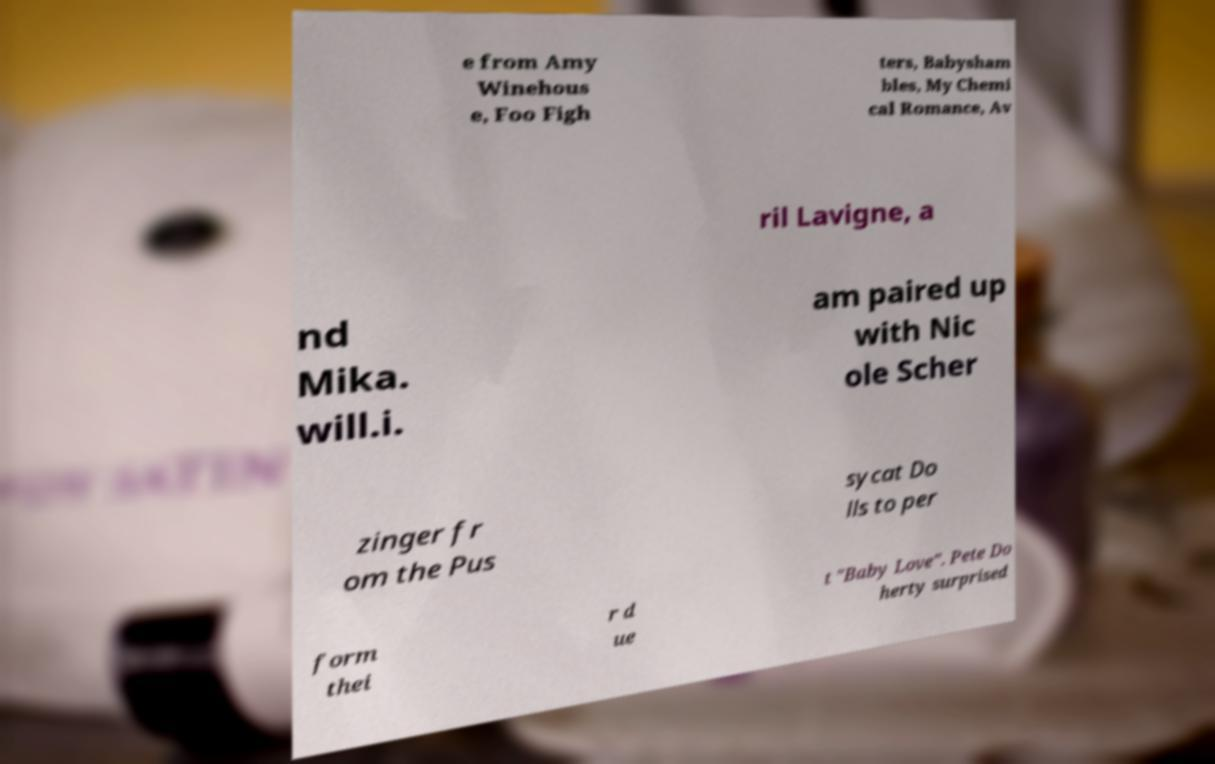For documentation purposes, I need the text within this image transcribed. Could you provide that? e from Amy Winehous e, Foo Figh ters, Babysham bles, My Chemi cal Romance, Av ril Lavigne, a nd Mika. will.i. am paired up with Nic ole Scher zinger fr om the Pus sycat Do lls to per form thei r d ue t "Baby Love". Pete Do herty surprised 